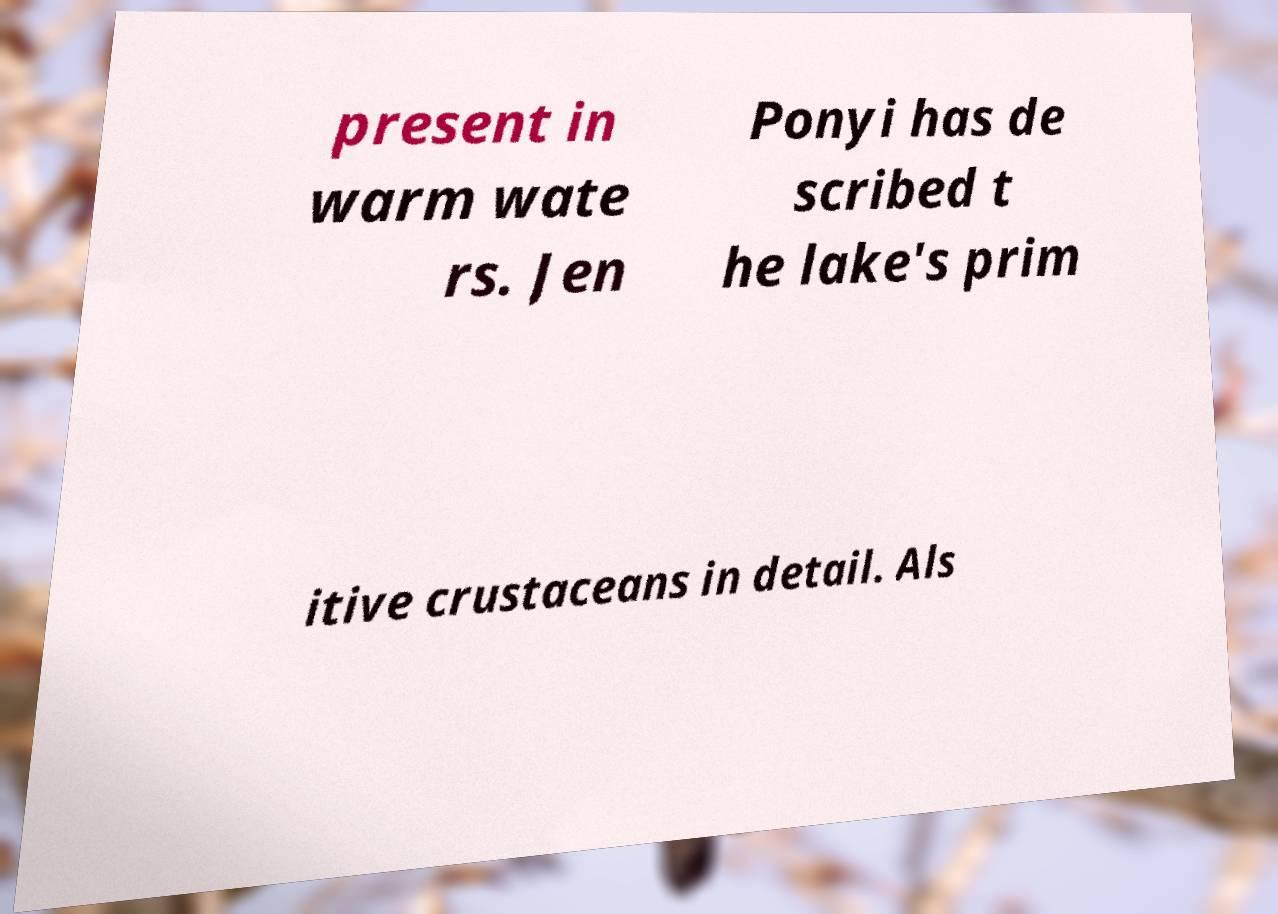Can you read and provide the text displayed in the image?This photo seems to have some interesting text. Can you extract and type it out for me? present in warm wate rs. Jen Ponyi has de scribed t he lake's prim itive crustaceans in detail. Als 